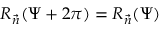Convert formula to latex. <formula><loc_0><loc_0><loc_500><loc_500>R _ { \vec { n } } ( \Psi + 2 \pi ) = R _ { \vec { n } } ( \Psi )</formula> 